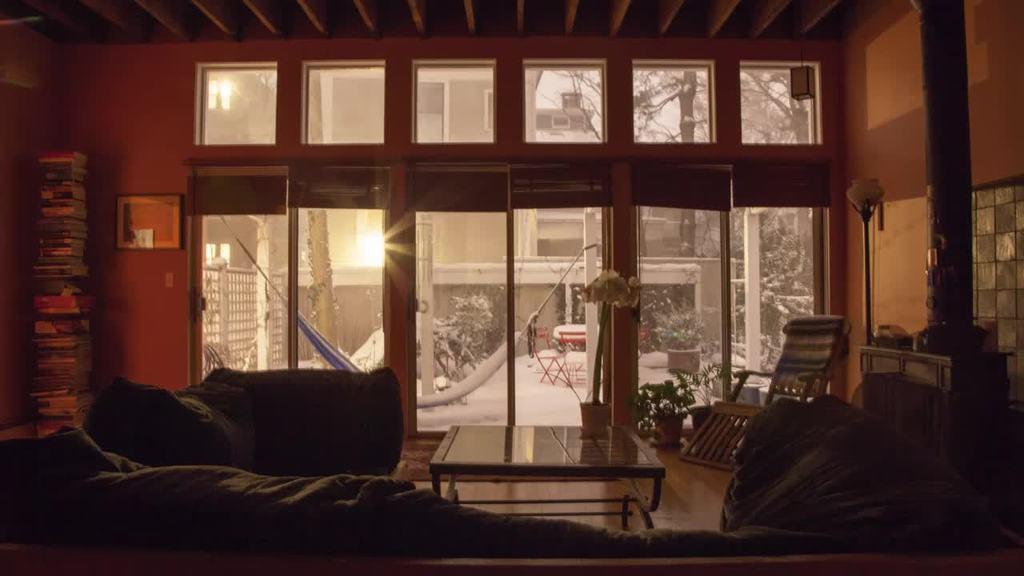Could you give a brief overview of what you see in this image? In the image we can see couch,table,books,house,glass door,plants,trees and few more objects around it. 